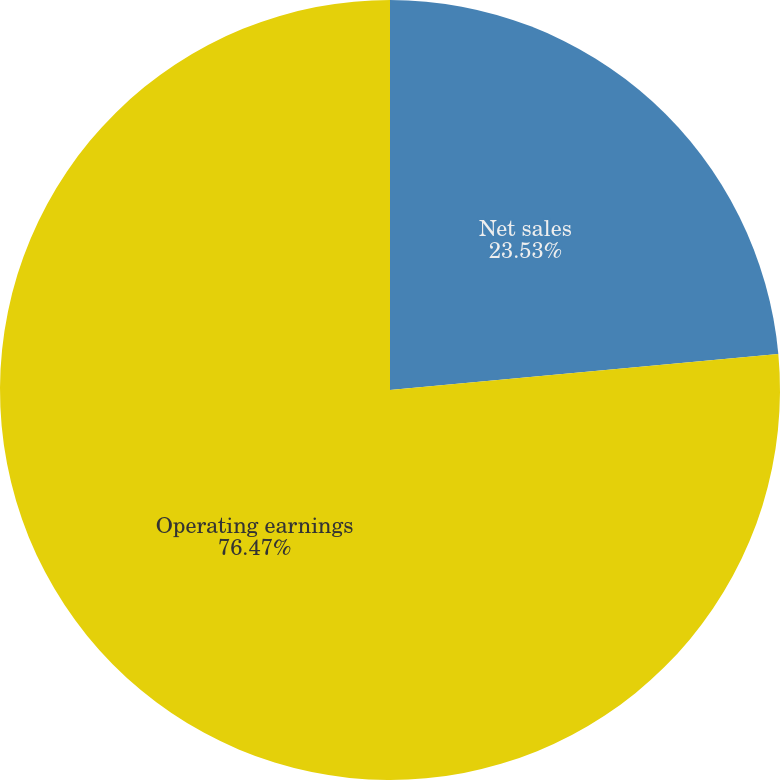<chart> <loc_0><loc_0><loc_500><loc_500><pie_chart><fcel>Net sales<fcel>Operating earnings<nl><fcel>23.53%<fcel>76.47%<nl></chart> 